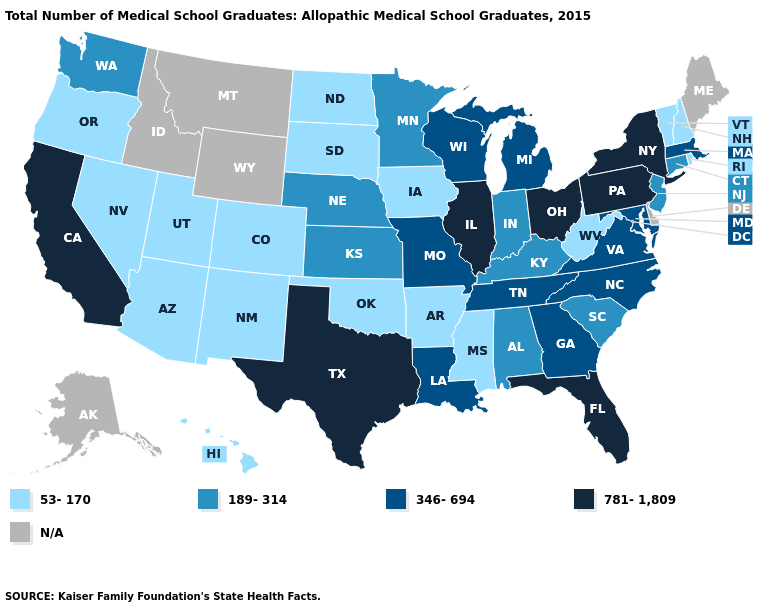What is the value of California?
Answer briefly. 781-1,809. Does the first symbol in the legend represent the smallest category?
Be succinct. Yes. Is the legend a continuous bar?
Concise answer only. No. Name the states that have a value in the range 346-694?
Answer briefly. Georgia, Louisiana, Maryland, Massachusetts, Michigan, Missouri, North Carolina, Tennessee, Virginia, Wisconsin. Which states have the lowest value in the USA?
Keep it brief. Arizona, Arkansas, Colorado, Hawaii, Iowa, Mississippi, Nevada, New Hampshire, New Mexico, North Dakota, Oklahoma, Oregon, Rhode Island, South Dakota, Utah, Vermont, West Virginia. What is the value of Illinois?
Concise answer only. 781-1,809. Which states have the lowest value in the USA?
Write a very short answer. Arizona, Arkansas, Colorado, Hawaii, Iowa, Mississippi, Nevada, New Hampshire, New Mexico, North Dakota, Oklahoma, Oregon, Rhode Island, South Dakota, Utah, Vermont, West Virginia. Among the states that border South Carolina , which have the lowest value?
Be succinct. Georgia, North Carolina. Name the states that have a value in the range 781-1,809?
Give a very brief answer. California, Florida, Illinois, New York, Ohio, Pennsylvania, Texas. Among the states that border Kentucky , which have the highest value?
Short answer required. Illinois, Ohio. What is the value of Maryland?
Be succinct. 346-694. What is the highest value in states that border Vermont?
Concise answer only. 781-1,809. Does the map have missing data?
Be succinct. Yes. 